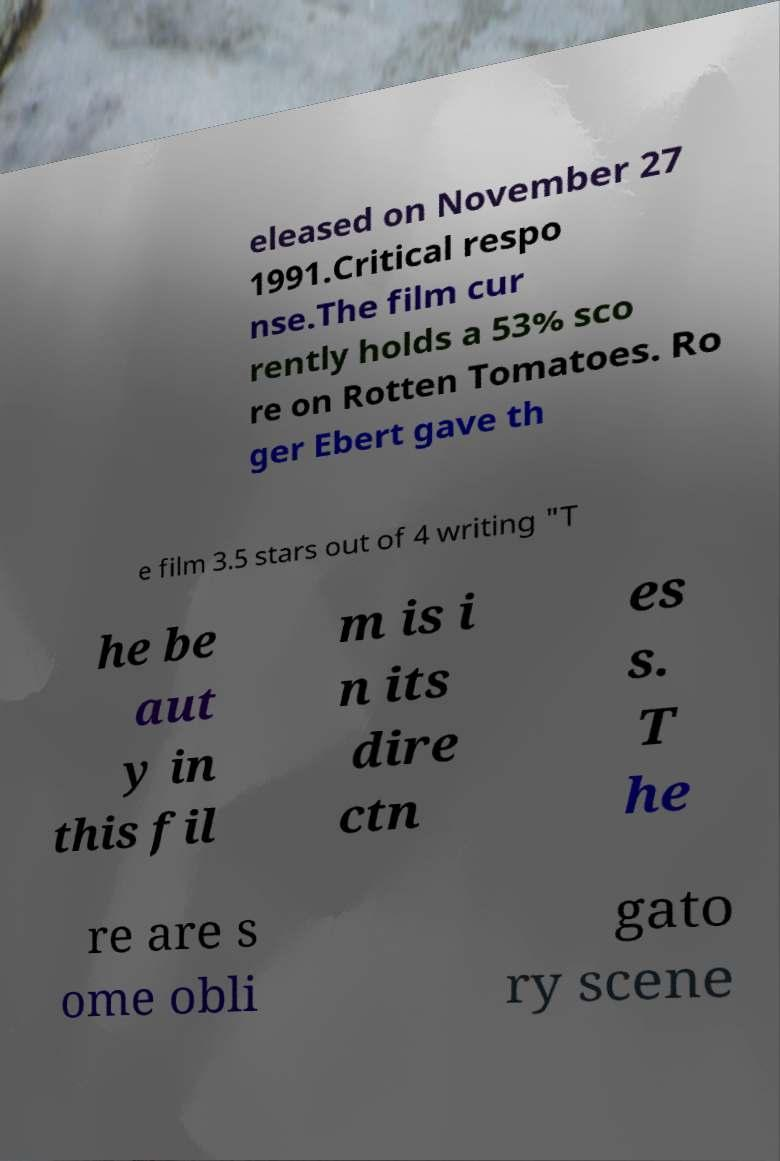Please identify and transcribe the text found in this image. eleased on November 27 1991.Critical respo nse.The film cur rently holds a 53% sco re on Rotten Tomatoes. Ro ger Ebert gave th e film 3.5 stars out of 4 writing "T he be aut y in this fil m is i n its dire ctn es s. T he re are s ome obli gato ry scene 